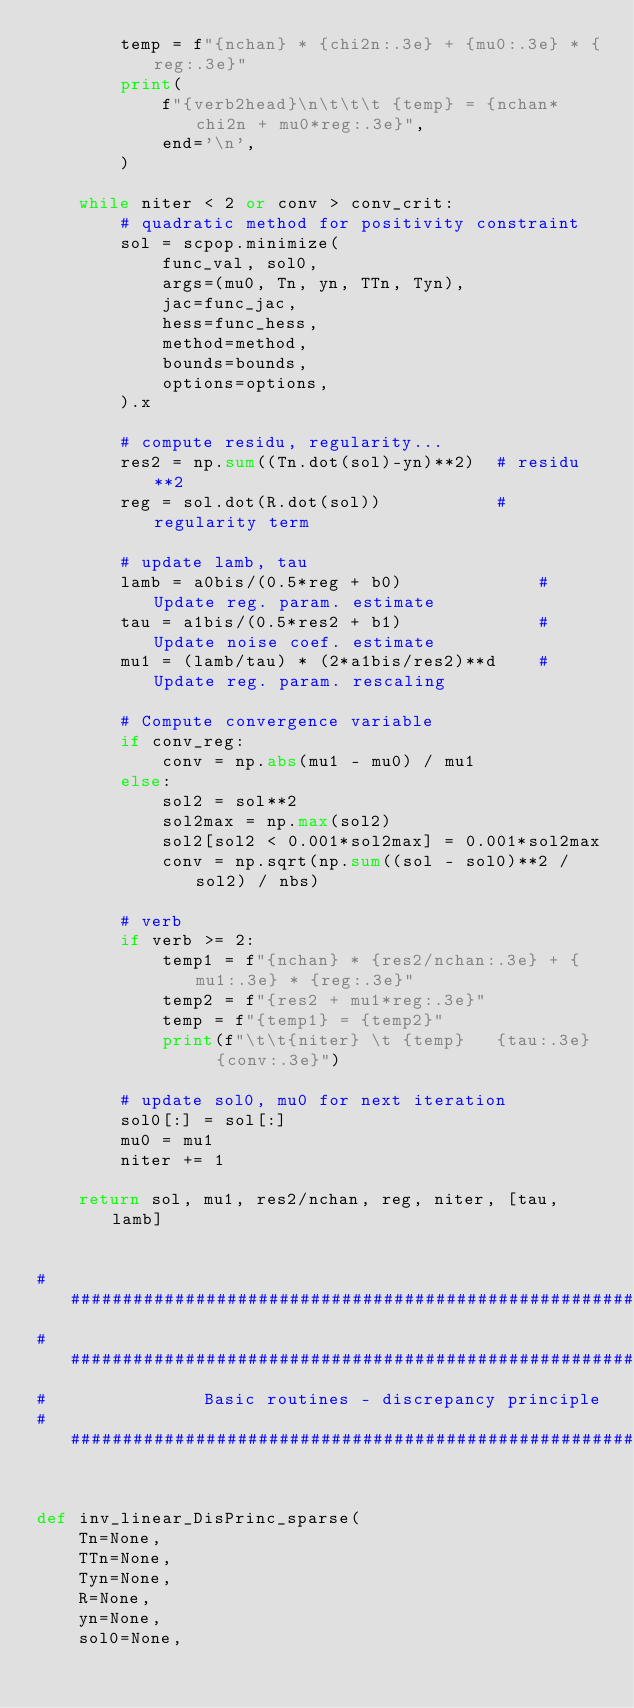<code> <loc_0><loc_0><loc_500><loc_500><_Python_>        temp = f"{nchan} * {chi2n:.3e} + {mu0:.3e} * {reg:.3e}"
        print(
            f"{verb2head}\n\t\t\t {temp} = {nchan*chi2n + mu0*reg:.3e}",
            end='\n',
        )

    while niter < 2 or conv > conv_crit:
        # quadratic method for positivity constraint
        sol = scpop.minimize(
            func_val, sol0,
            args=(mu0, Tn, yn, TTn, Tyn),
            jac=func_jac,
            hess=func_hess,
            method=method,
            bounds=bounds,
            options=options,
        ).x

        # compute residu, regularity...
        res2 = np.sum((Tn.dot(sol)-yn)**2)  # residu**2
        reg = sol.dot(R.dot(sol))           # regularity term

        # update lamb, tau
        lamb = a0bis/(0.5*reg + b0)             # Update reg. param. estimate
        tau = a1bis/(0.5*res2 + b1)             # Update noise coef. estimate
        mu1 = (lamb/tau) * (2*a1bis/res2)**d    # Update reg. param. rescaling

        # Compute convergence variable
        if conv_reg:
            conv = np.abs(mu1 - mu0) / mu1
        else:
            sol2 = sol**2
            sol2max = np.max(sol2)
            sol2[sol2 < 0.001*sol2max] = 0.001*sol2max
            conv = np.sqrt(np.sum((sol - sol0)**2 / sol2) / nbs)

        # verb
        if verb >= 2:
            temp1 = f"{nchan} * {res2/nchan:.3e} + {mu1:.3e} * {reg:.3e}"
            temp2 = f"{res2 + mu1*reg:.3e}"
            temp = f"{temp1} = {temp2}"
            print(f"\t\t{niter} \t {temp}   {tau:.3e}   {conv:.3e}")

        # update sol0, mu0 for next iteration
        sol0[:] = sol[:]
        mu0 = mu1
        niter += 1

    return sol, mu1, res2/nchan, reg, niter, [tau, lamb]


# #############################################################################
# #############################################################################
#               Basic routines - discrepancy principle
# #############################################################################


def inv_linear_DisPrinc_sparse(
    Tn=None,
    TTn=None,
    Tyn=None,
    R=None,
    yn=None,
    sol0=None,</code> 